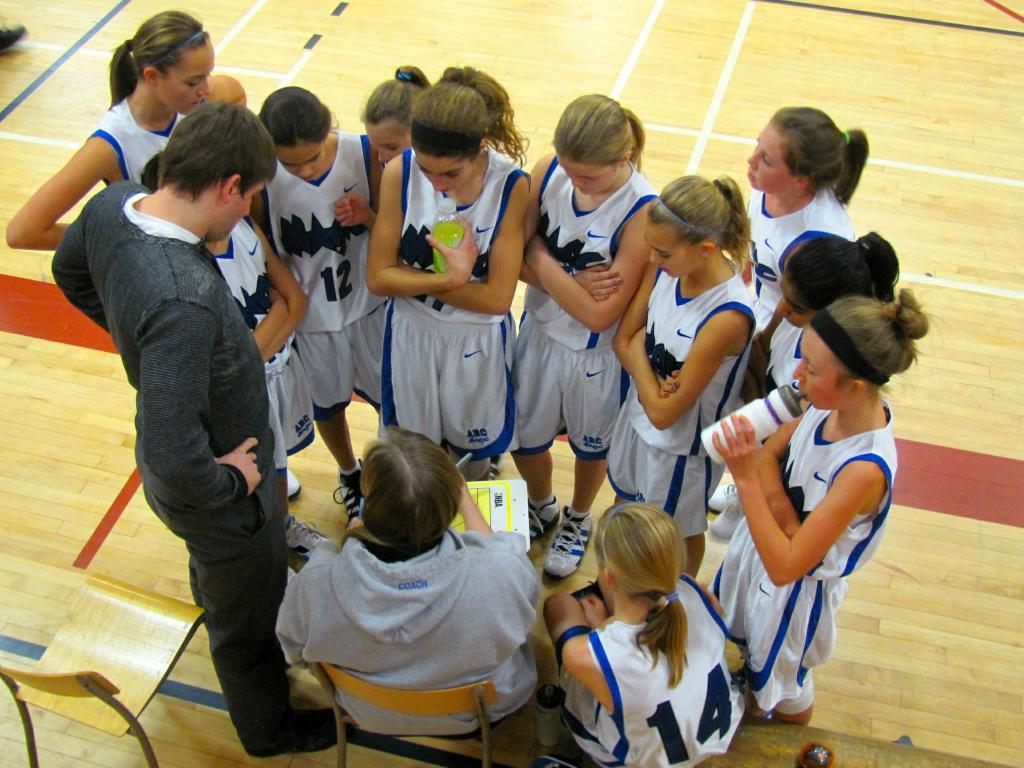<image>
Share a concise interpretation of the image provided. A girl's basketball team standing in a circle next to their coach, one of them who has a number 12 jersey. 